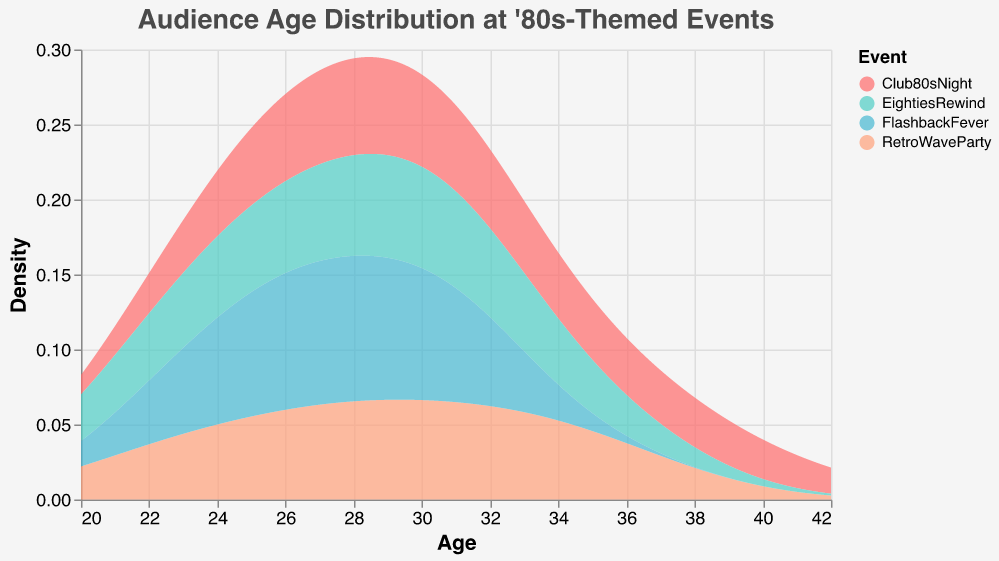What's the title of the figure? The title is typically located at the top of the figure; you can read it directly from there.
Answer: Audience Age Distribution at '80s-Themed Events What events are included in the figure? The events are represented by different colors in the legend, which lists all the events included.
Answer: Club80sNight, RetroWaveParty, EightiesRewind, FlashbackFever Which event has the highest peak density? Look at the density plot and identify which event's line or filled area reaches the highest point on the y-axis.
Answer: RetroWaveParty In which age range does the highest density for "Club80sNight" occur? You need to find the peak of the density curve for "Club80sNight" and read off the corresponding age range on the x-axis.
Answer: Around 28-30 What is the general trend of the audience age distribution across the events? Observe the density plot curves for all events and summarize the common patterns or trends in age distribution.
Answer: The peak densities often occur in the mid to late 20s and early 30s for most events Which event has a broader age distribution? Look at the spread of the density curves along the x-axis (age) for each event; the event with the widest spread has the broader age distribution.
Answer: Club80sNight How does the age density of "FlashbackFever" compare to "EightiesRewind" between ages 24 and 30? Compare the height of the density curves of "FlashbackFever" and "EightiesRewind" in the given age range on the x-axis.
Answer: FlashbackFever generally has a higher density At what age do all events show low audience density? Identify a point along the x-axis (age) where all density curves are relatively low.
Answer: Around age 40 Does any event have a significant older audience (35+)? Look for density curves that have noticeable peaks or spread in the older age range (35+).
Answer: Club80sNight and RetroWaveParty show higher densities in the older age group 